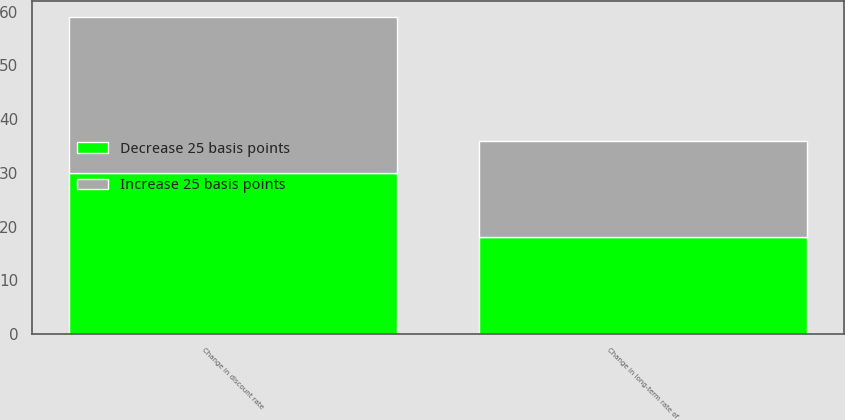Convert chart. <chart><loc_0><loc_0><loc_500><loc_500><stacked_bar_chart><ecel><fcel>Change in discount rate<fcel>Change in long-term rate of<nl><fcel>Increase 25 basis points<fcel>29<fcel>18<nl><fcel>Decrease 25 basis points<fcel>30<fcel>18<nl></chart> 